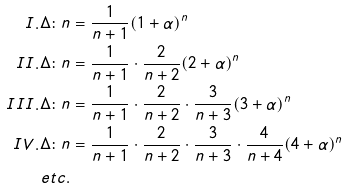Convert formula to latex. <formula><loc_0><loc_0><loc_500><loc_500>I . \Delta \colon n & = \frac { 1 } { n + 1 } ( 1 + \alpha ) ^ { n } \\ I I . \Delta \colon n & = \frac { 1 } { n + 1 } \cdot \frac { 2 } { n + 2 } ( 2 + \alpha ) ^ { n } \\ I I I . \Delta \colon n & = \frac { 1 } { n + 1 } \cdot \frac { 2 } { n + 2 } \cdot \frac { 3 } { n + 3 } ( 3 + \alpha ) ^ { n } \\ I V . \Delta \colon n & = \frac { 1 } { n + 1 } \cdot \frac { 2 } { n + 2 } \cdot \frac { 3 } { n + 3 } \cdot \frac { 4 } { n + 4 } ( 4 + \alpha ) ^ { n } \\ e t c . & &</formula> 